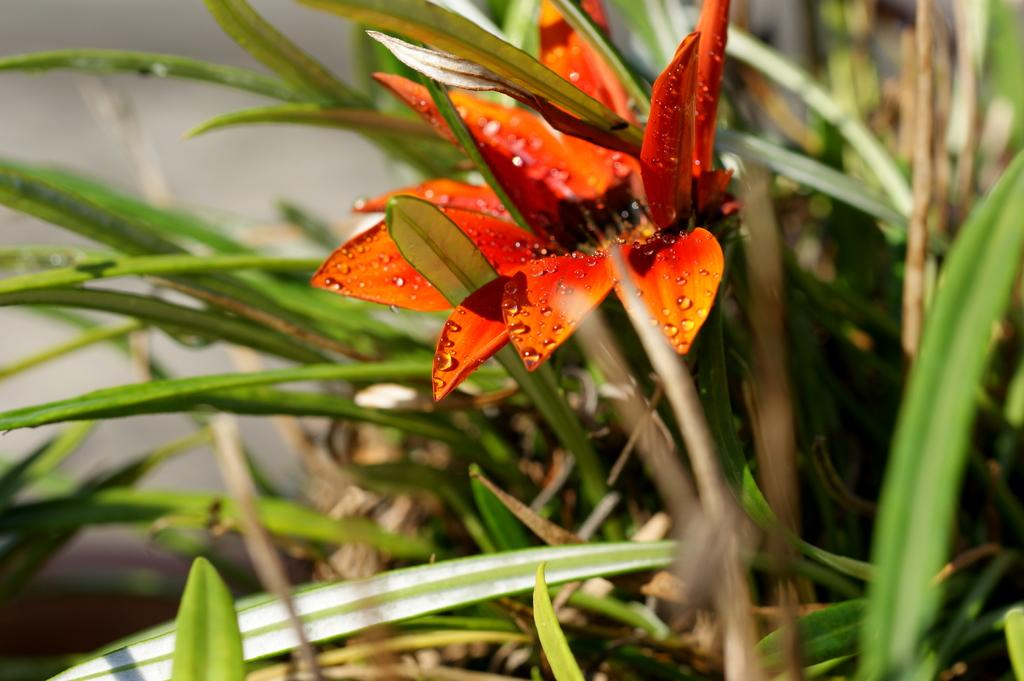What is the main subject of the image? There is a flower in the image. Can you describe the flower's location? The flower is on a plant. What riddle does the flower pose in the image? There is no riddle posed by the flower in the image. Can you describe how the flower jumps in the image? Flowers do not have the ability to jump, so this action cannot be observed in the image. 